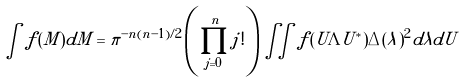<formula> <loc_0><loc_0><loc_500><loc_500>\int f ( M ) d M = \pi ^ { - n ( n - 1 ) / 2 } \left ( \prod _ { j = 0 } ^ { n } j ! \right ) \iint f ( U \Lambda U ^ { * } ) \Delta ( \lambda ) ^ { 2 } d \lambda d U</formula> 